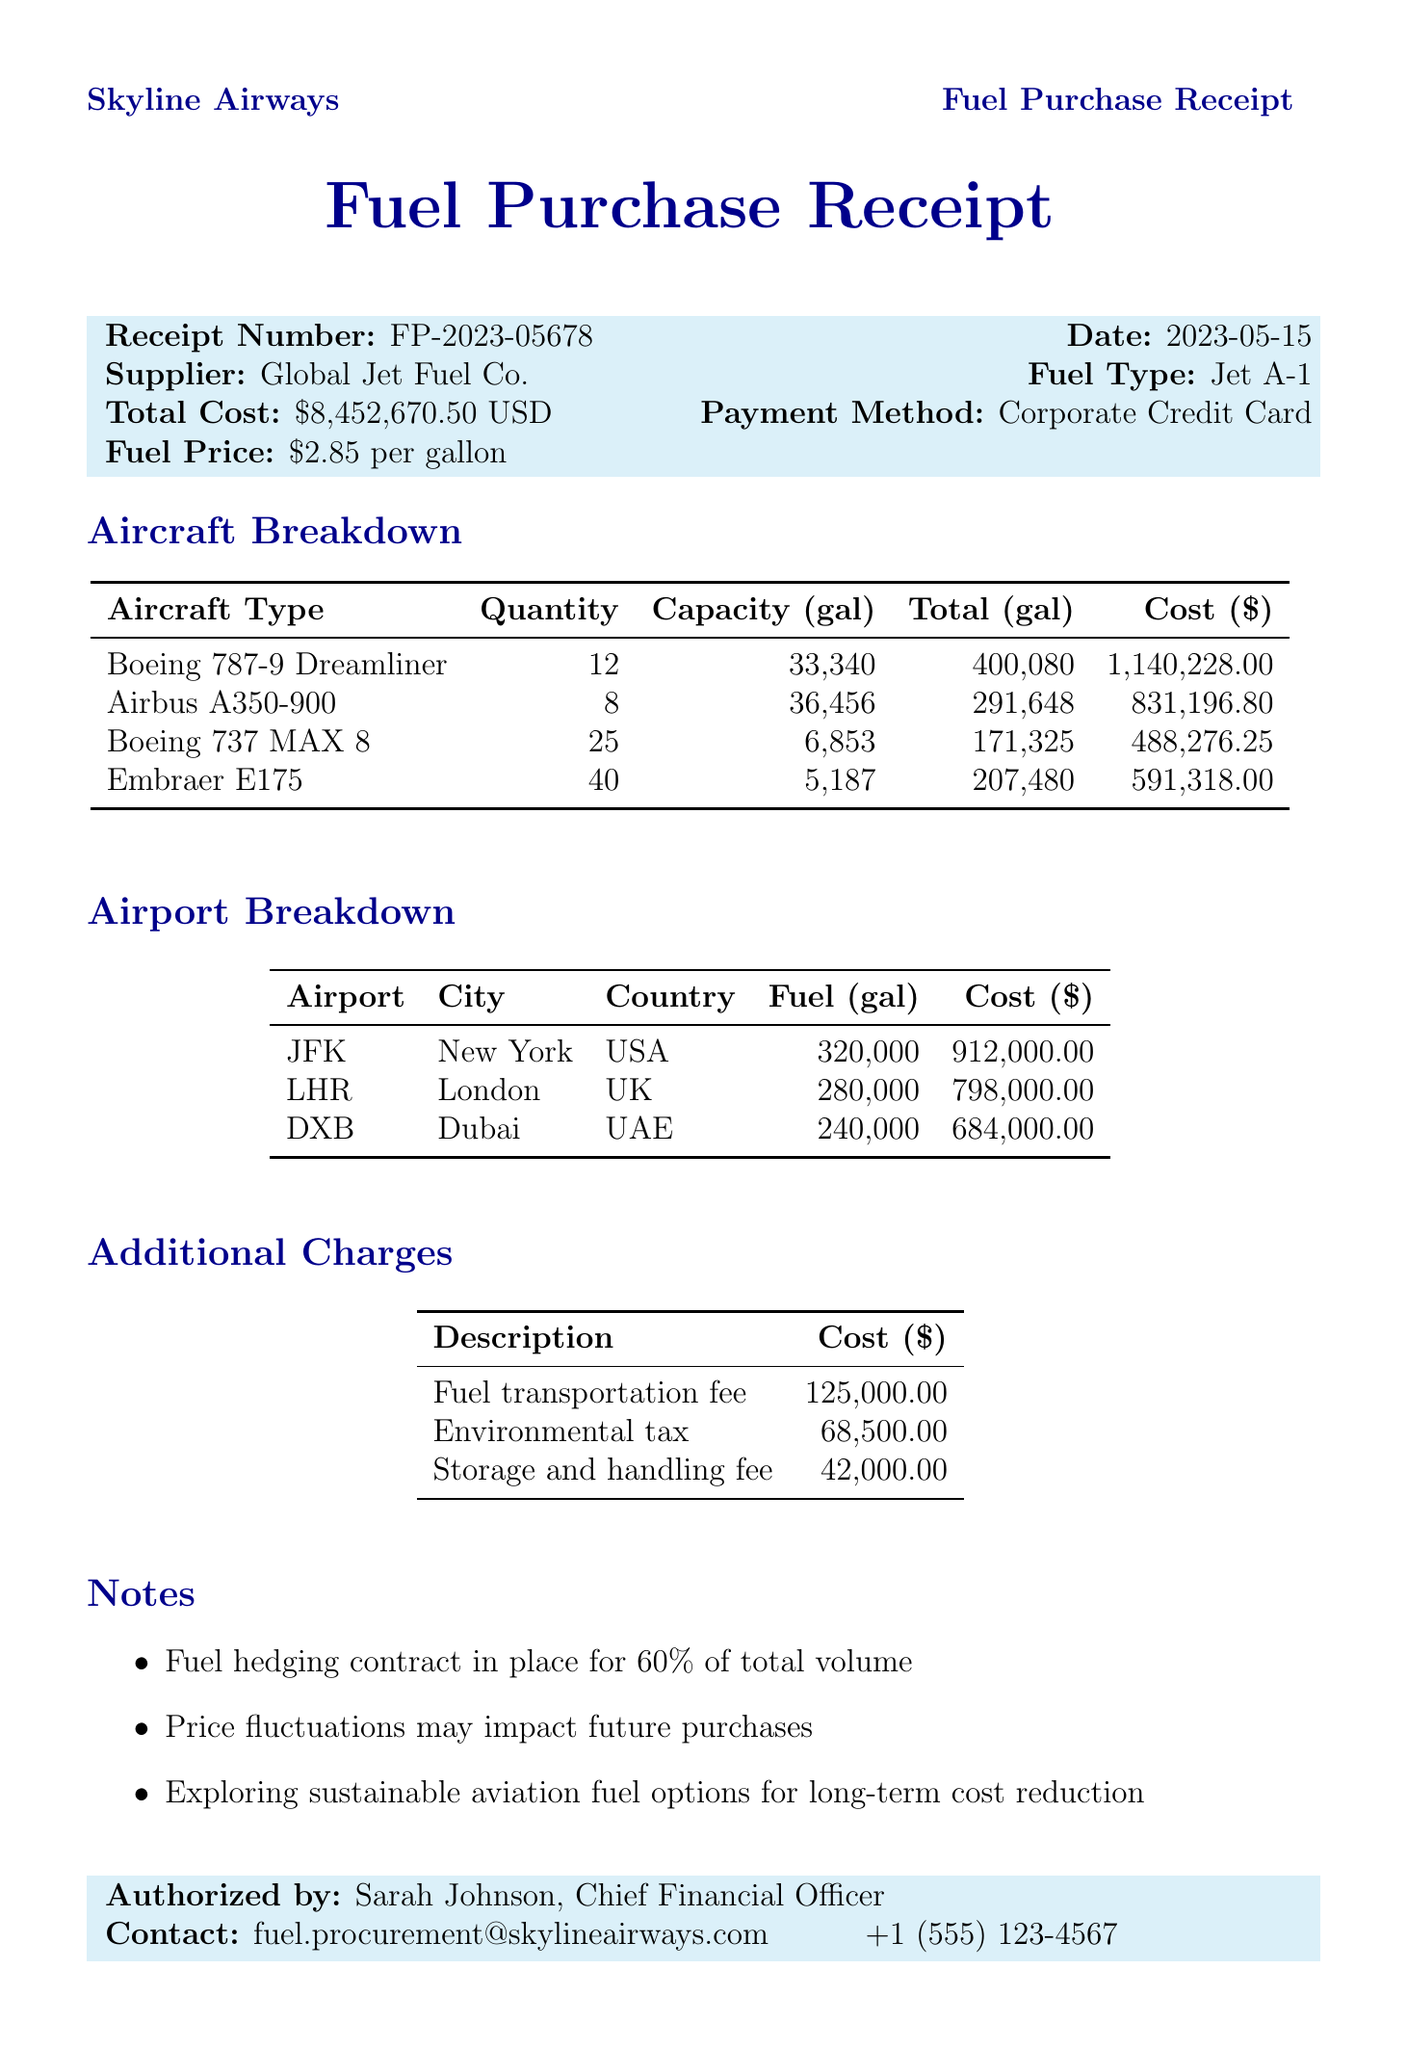what is the total cost of the fuel purchase? The total cost is stated clearly at the top of the document as $8,452,670.50.
Answer: $8,452,670.50 who is the authorized person for this receipt? The authorized person is mentioned at the bottom of the document as Sarah Johnson, Chief Financial Officer.
Answer: Sarah Johnson, Chief Financial Officer how many Airbus A350-900 aircraft are included in the fuel purchase? The aircraft breakdown section shows that there are 8 Airbus A350-900 aircraft.
Answer: 8 what is the fuel type purchased? The fuel type is indicated in the document as Jet A-1.
Answer: Jet A-1 what is the fuel price per gallon? The fuel price per gallon is specified as $2.85.
Answer: $2.85 how much was paid for environmental tax? The additional charges table lists the environmental tax cost as $68,500.00.
Answer: $68,500.00 which airport has the highest fuel cost? By comparing the costs in the airport breakdown, London Heathrow Airport has the highest cost of $798,000.00.
Answer: London Heathrow Airport how many gallons of fuel were purchased for the Boeing 737 MAX 8? The total fuel gallons for the Boeing 737 MAX 8 is stated in the aircraft breakdown as 171,325 gallons.
Answer: 171,325 what additional charge is specifically for transportation? The additional charge for transportation is labeled as the fuel transportation fee.
Answer: fuel transportation fee 